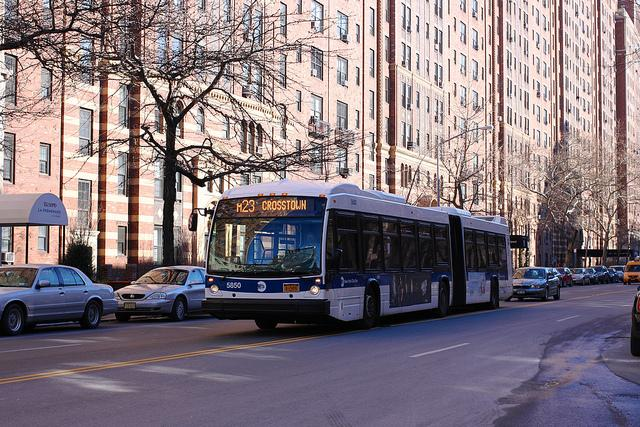What type of parking is shown? Please explain your reasoning. parallel. There is parking on the street where there are rows of cars lined up. 